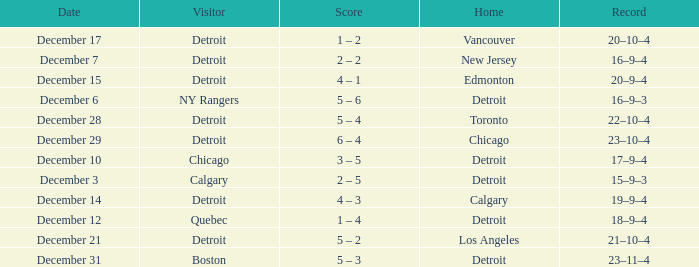Who is the visitor on december 3? Calgary. 